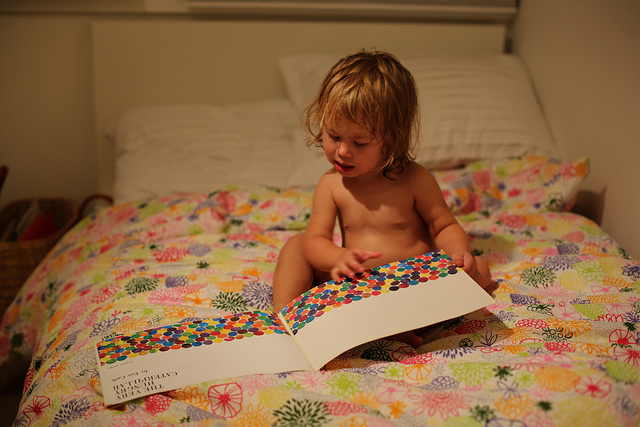<image>Is there a black headband on the bed? No, there is no black headband on the bed. Is there a black headband on the bed? There is no black headband on the bed. 